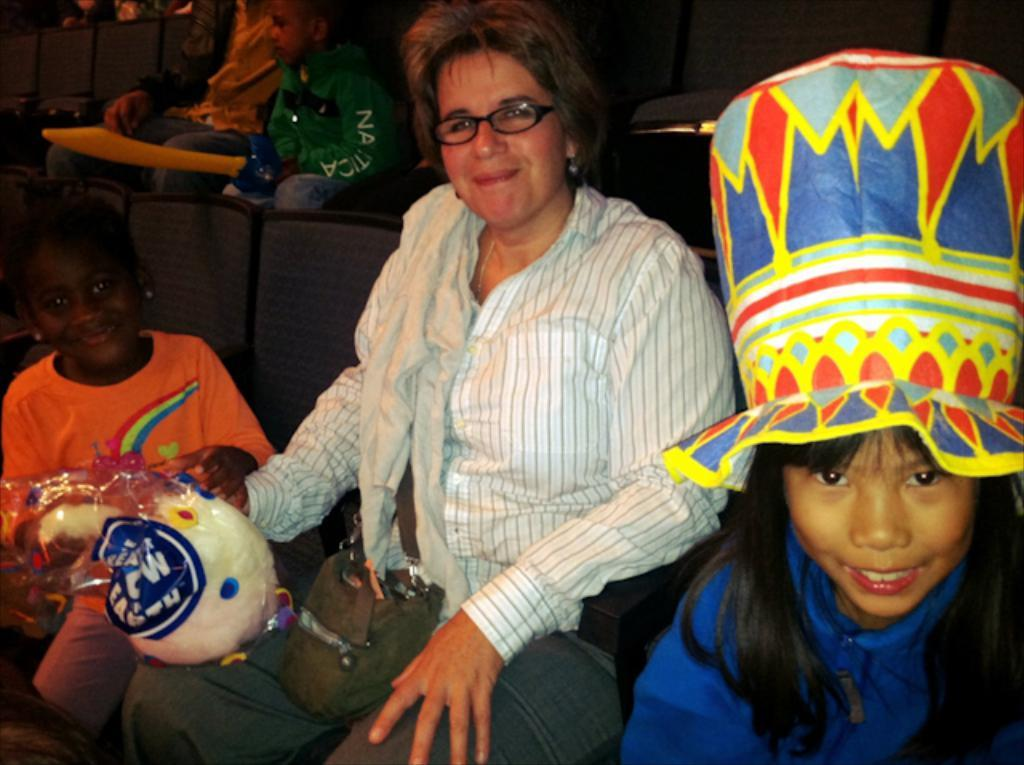What is the main subject in the center of the image? There is a person sitting on a chair in the center of the image. What can be seen in the background of the image? There are chairs and other persons in the background of the image. What type of skate is being used by the person in the image? There is no skate present in the image; the person is sitting on a chair. 